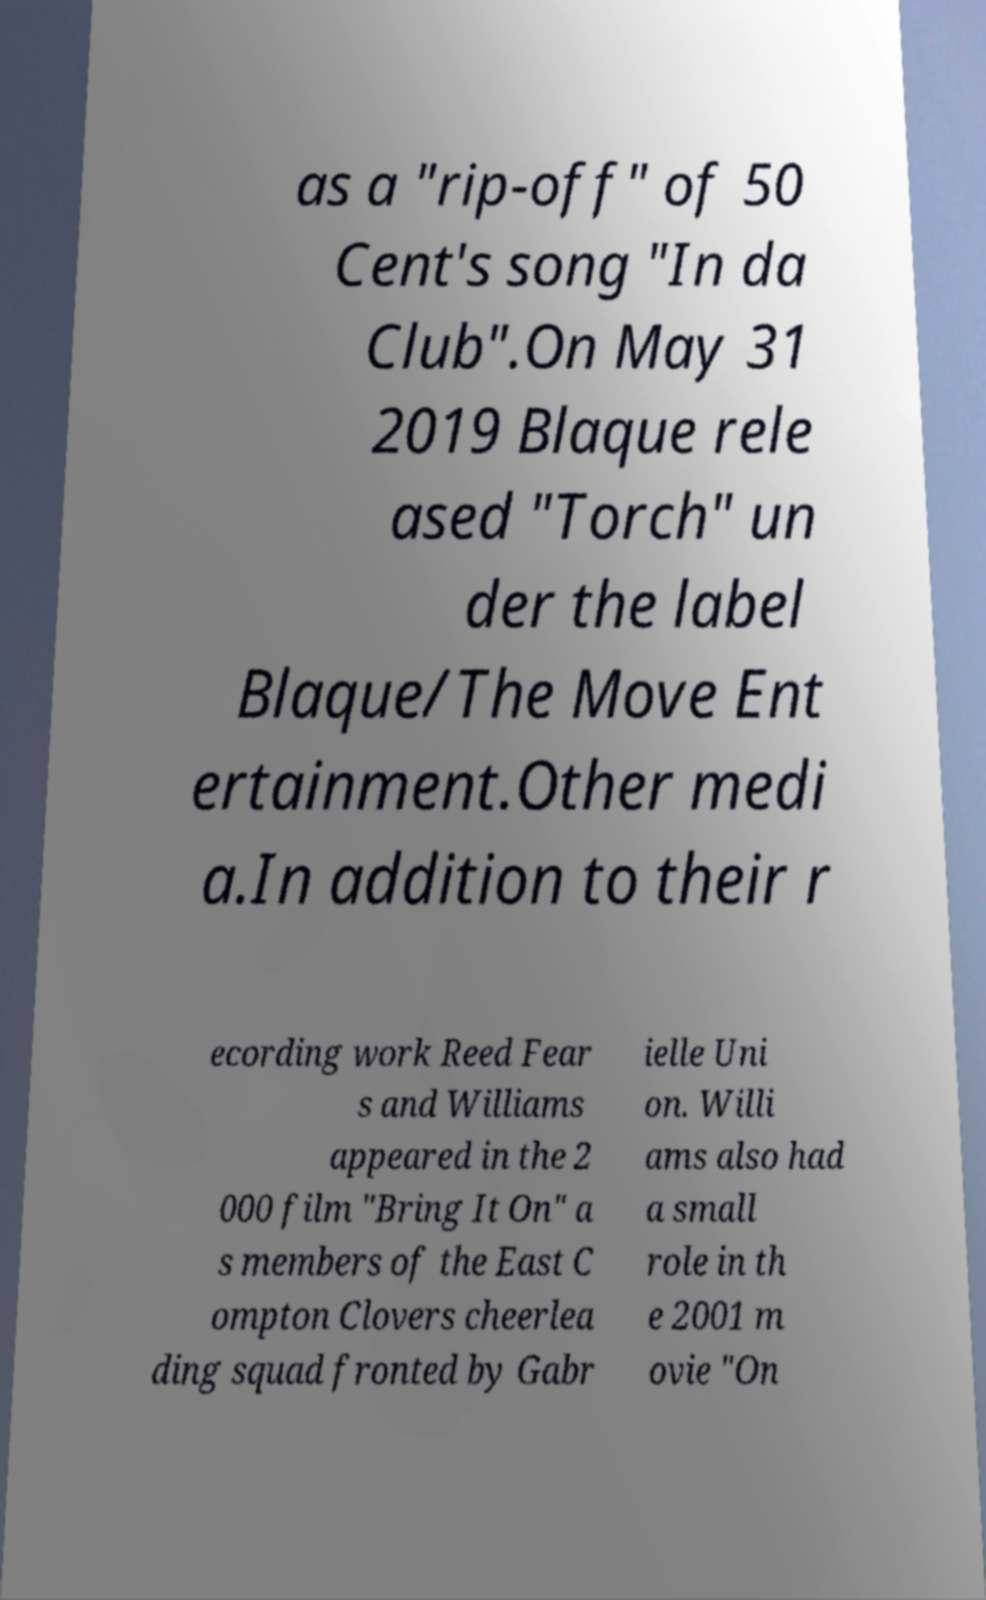Please identify and transcribe the text found in this image. as a "rip-off" of 50 Cent's song "In da Club".On May 31 2019 Blaque rele ased "Torch" un der the label Blaque/The Move Ent ertainment.Other medi a.In addition to their r ecording work Reed Fear s and Williams appeared in the 2 000 film "Bring It On" a s members of the East C ompton Clovers cheerlea ding squad fronted by Gabr ielle Uni on. Willi ams also had a small role in th e 2001 m ovie "On 